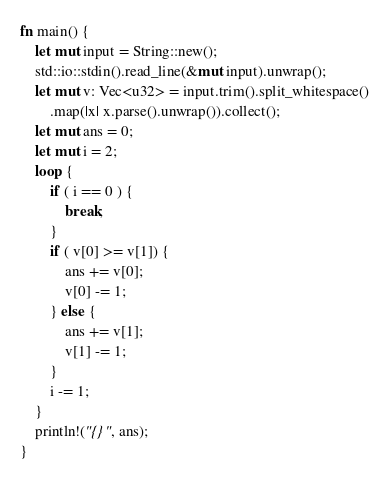Convert code to text. <code><loc_0><loc_0><loc_500><loc_500><_Rust_>fn main() {
    let mut input = String::new();
    std::io::stdin().read_line(&mut input).unwrap();
    let mut v: Vec<u32> = input.trim().split_whitespace()
        .map(|x| x.parse().unwrap()).collect();
    let mut ans = 0;
    let mut i = 2;
    loop {
        if ( i == 0 ) {
            break;
        }
        if ( v[0] >= v[1]) {
            ans += v[0];
            v[0] -= 1;
        } else {
            ans += v[1];
            v[1] -= 1;
        }
        i -= 1;
    }
    println!("{}", ans);
}</code> 